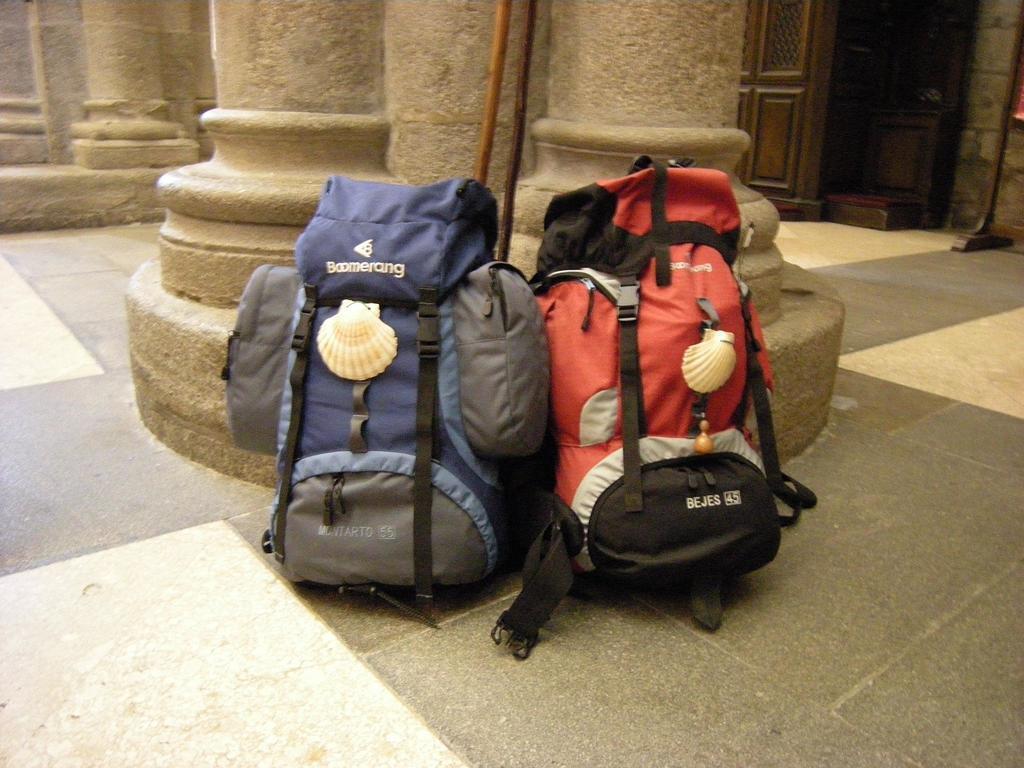In one or two sentences, can you explain what this image depicts? In this image we can see two bags. One is on the left side and the other one is on the right side. In the background we can see a wooden door. 